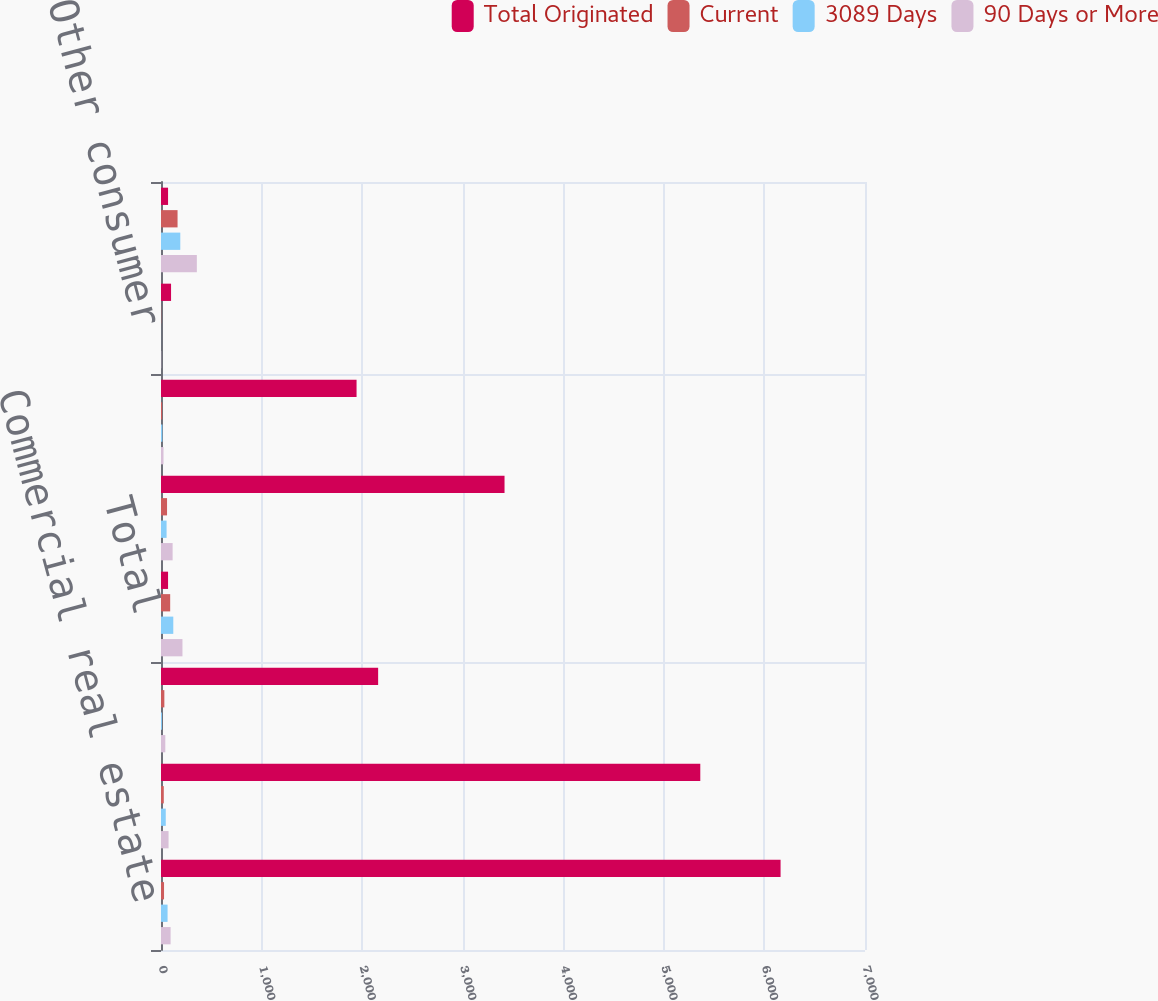Convert chart to OTSL. <chart><loc_0><loc_0><loc_500><loc_500><stacked_bar_chart><ecel><fcel>Commercial real estate<fcel>Commercial and industrial<fcel>Equipment financing<fcel>Total<fcel>Residential mortgage<fcel>Home equity<fcel>Other consumer<fcel>Total originated loans<nl><fcel>Total Originated<fcel>6160.6<fcel>5362.3<fcel>2159<fcel>70.2<fcel>3415.8<fcel>1944.5<fcel>100<fcel>70.2<nl><fcel>Current<fcel>30.2<fcel>27.7<fcel>33.4<fcel>91.3<fcel>60.1<fcel>11.2<fcel>2<fcel>164.6<nl><fcel>3089 Days<fcel>65.3<fcel>47.4<fcel>9.5<fcel>122.2<fcel>55.5<fcel>13.7<fcel>0.3<fcel>191.7<nl><fcel>90 Days or More<fcel>95.5<fcel>75.1<fcel>42.9<fcel>213.5<fcel>115.6<fcel>24.9<fcel>2.3<fcel>356.3<nl></chart> 